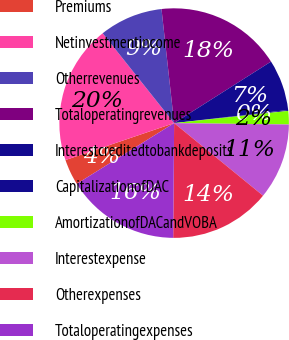Convert chart to OTSL. <chart><loc_0><loc_0><loc_500><loc_500><pie_chart><fcel>Premiums<fcel>Netinvestmentincome<fcel>Otherrevenues<fcel>Totaloperatingrevenues<fcel>Interestcreditedtobankdeposits<fcel>CapitalizationofDAC<fcel>AmortizationofDACandVOBA<fcel>Interestexpense<fcel>Otherexpenses<fcel>Totaloperatingexpenses<nl><fcel>3.66%<fcel>19.52%<fcel>8.94%<fcel>17.75%<fcel>7.18%<fcel>0.13%<fcel>1.89%<fcel>10.7%<fcel>14.23%<fcel>15.99%<nl></chart> 